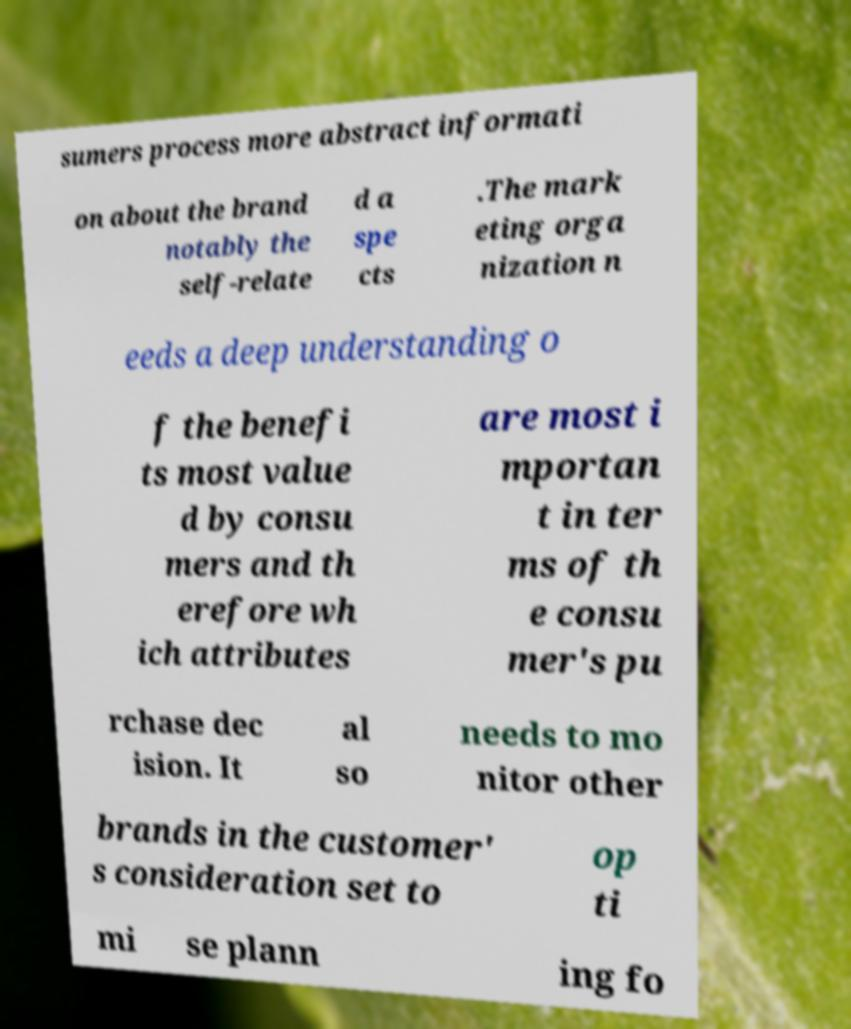Please read and relay the text visible in this image. What does it say? sumers process more abstract informati on about the brand notably the self-relate d a spe cts .The mark eting orga nization n eeds a deep understanding o f the benefi ts most value d by consu mers and th erefore wh ich attributes are most i mportan t in ter ms of th e consu mer's pu rchase dec ision. It al so needs to mo nitor other brands in the customer' s consideration set to op ti mi se plann ing fo 